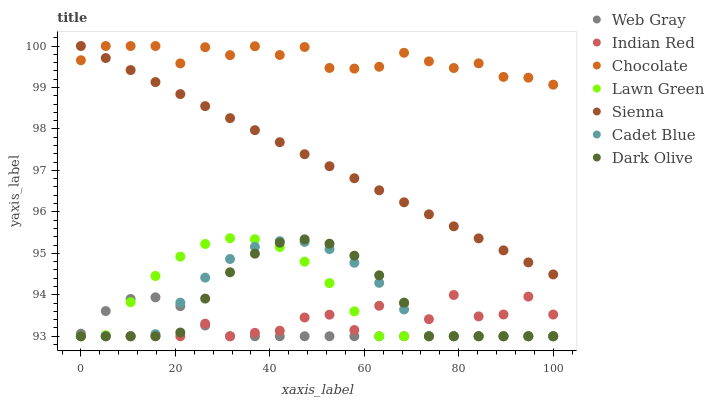Does Web Gray have the minimum area under the curve?
Answer yes or no. Yes. Does Chocolate have the maximum area under the curve?
Answer yes or no. Yes. Does Dark Olive have the minimum area under the curve?
Answer yes or no. No. Does Dark Olive have the maximum area under the curve?
Answer yes or no. No. Is Sienna the smoothest?
Answer yes or no. Yes. Is Indian Red the roughest?
Answer yes or no. Yes. Is Web Gray the smoothest?
Answer yes or no. No. Is Web Gray the roughest?
Answer yes or no. No. Does Lawn Green have the lowest value?
Answer yes or no. Yes. Does Chocolate have the lowest value?
Answer yes or no. No. Does Sienna have the highest value?
Answer yes or no. Yes. Does Dark Olive have the highest value?
Answer yes or no. No. Is Cadet Blue less than Sienna?
Answer yes or no. Yes. Is Sienna greater than Indian Red?
Answer yes or no. Yes. Does Indian Red intersect Dark Olive?
Answer yes or no. Yes. Is Indian Red less than Dark Olive?
Answer yes or no. No. Is Indian Red greater than Dark Olive?
Answer yes or no. No. Does Cadet Blue intersect Sienna?
Answer yes or no. No. 